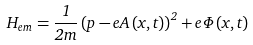<formula> <loc_0><loc_0><loc_500><loc_500>H _ { e m } = \frac { 1 } { 2 m } \left ( p - e A \left ( x , t \right ) \right ) ^ { 2 } + e \Phi \left ( x , t \right )</formula> 